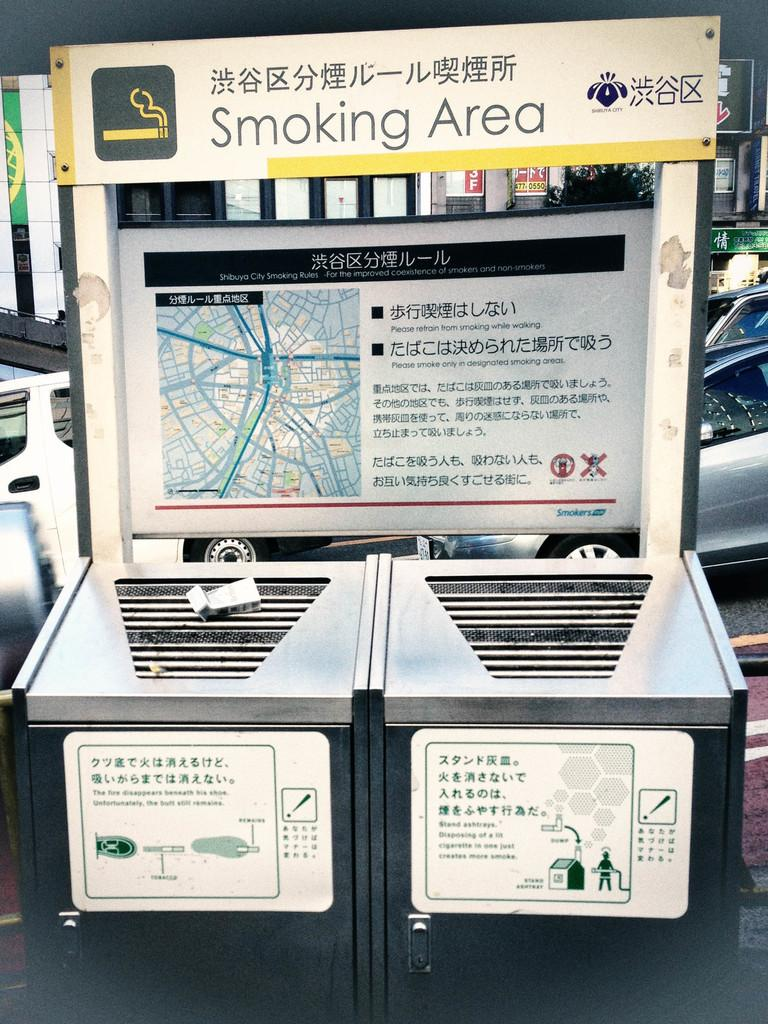What type of containers are in the foreground of the image? There are stainless steel boxes in the foreground of the image. What message is conveyed by the board at the top of the image? There is a caution board at the top of the image, which may indicate a warning or safety message. What can be seen in the background of the image? Cars are visible in the background of the image. What type of plough is being used to cultivate the field in the image? There is no field or plough present in the image; it features stainless steel boxes, a caution board, and cars in the background. How many light bulbs are visible in the image? There is no light bulb present in the image. 